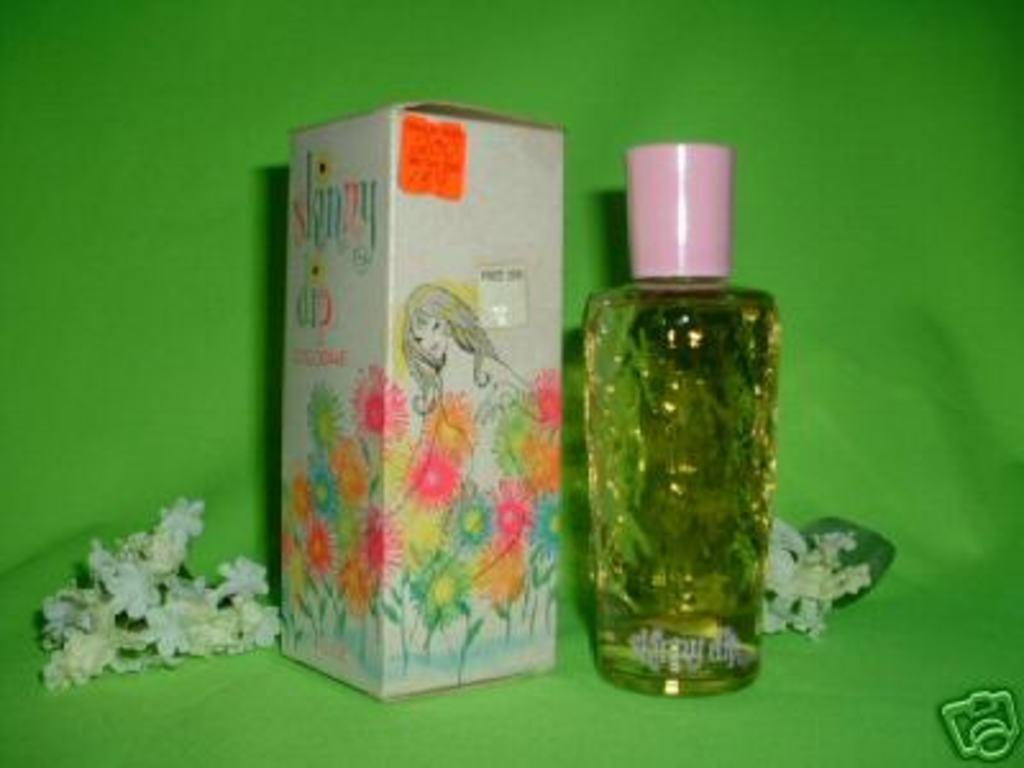<image>
Render a clear and concise summary of the photo. Perfume bottle next to a box that has the letter Y in green. 